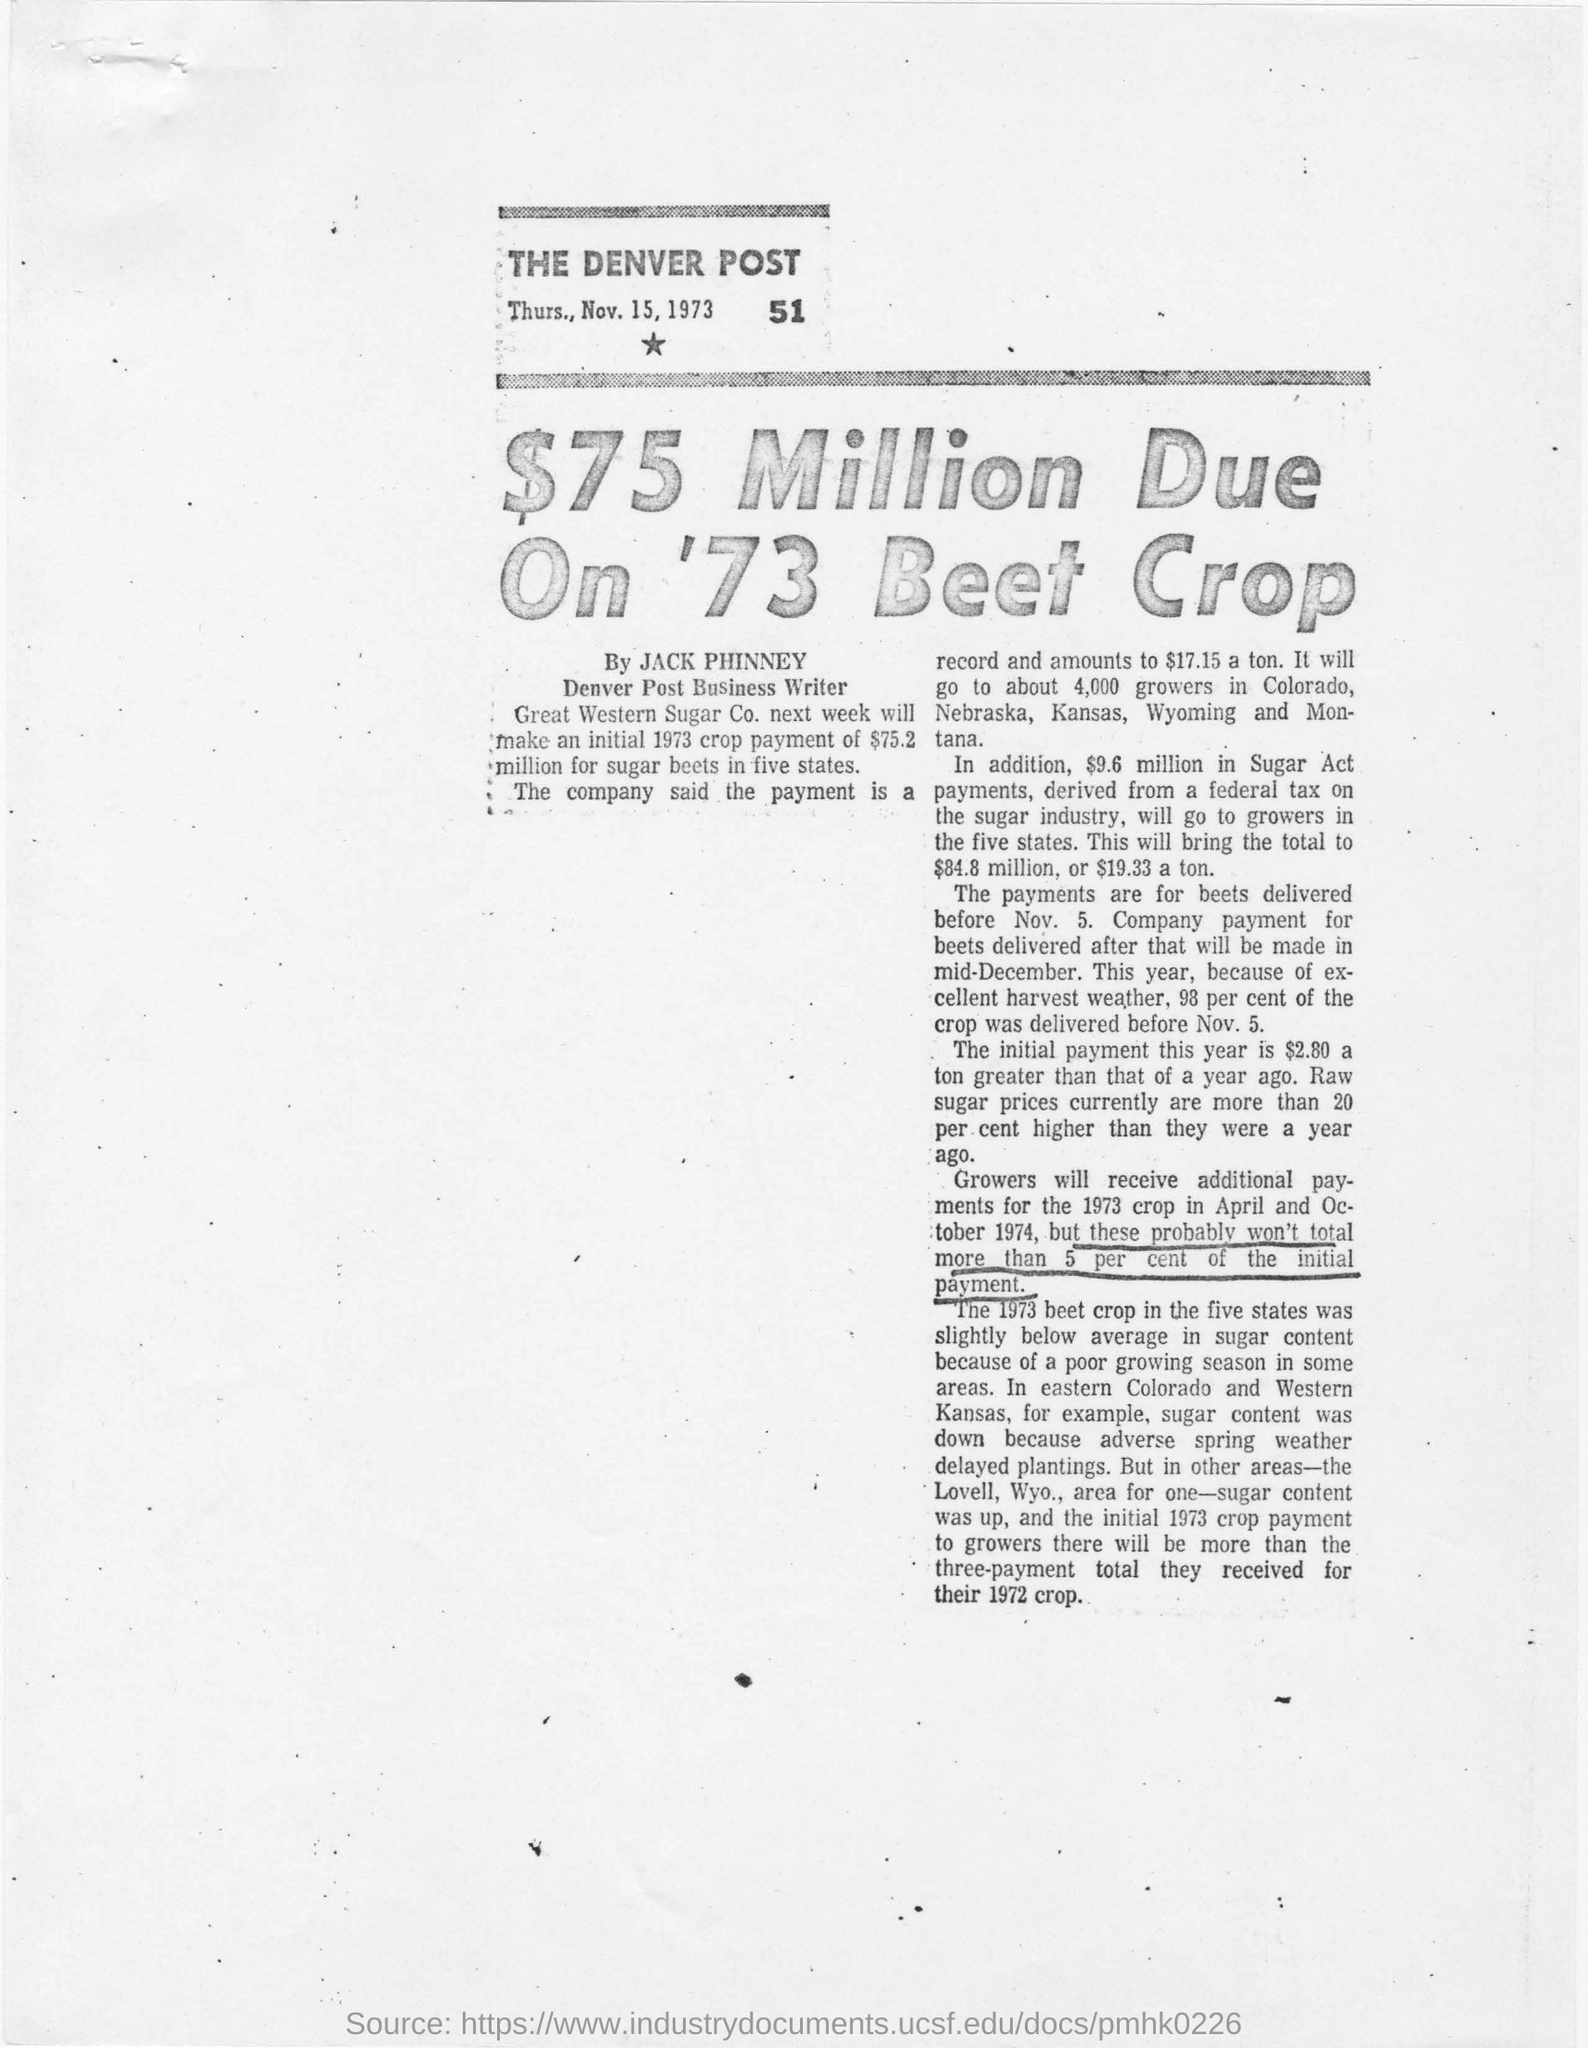What is the date on which this article is published?
Ensure brevity in your answer.  Thurs., Nov. 15, 1973. Who is  Denver post business writer ?
Offer a very short reply. Jack phinney. What is the title of this page?
Your answer should be compact. $75 Million due on '73 beet crop. Which company next week will make an intial 1973 crop payment of $75.2 million for sugar beets in five states?
Ensure brevity in your answer.  Great western sugar co. In which areas sugar content was down because adverse spring weather delayed planting ?
Offer a very short reply. Eastern colorado and western kansas. Which news paper is this?
Your answer should be compact. The denver post. 